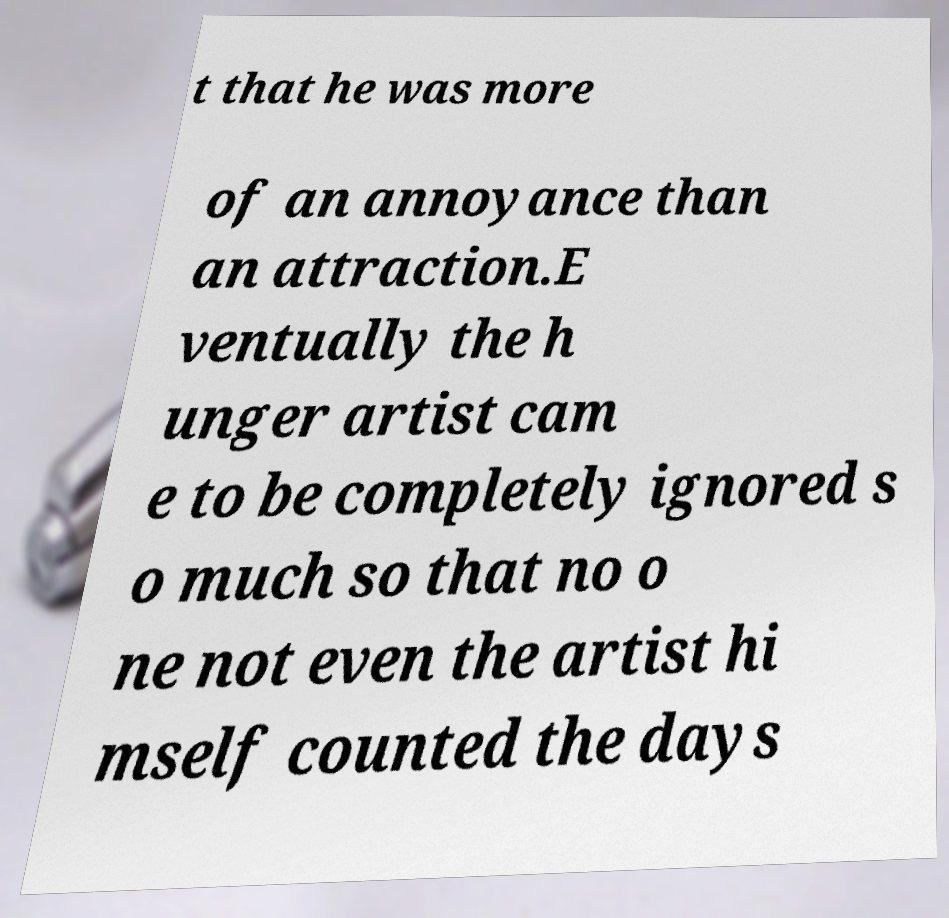There's text embedded in this image that I need extracted. Can you transcribe it verbatim? t that he was more of an annoyance than an attraction.E ventually the h unger artist cam e to be completely ignored s o much so that no o ne not even the artist hi mself counted the days 